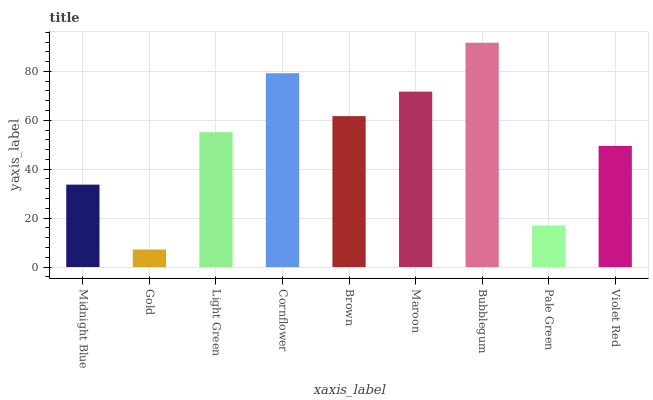Is Gold the minimum?
Answer yes or no. Yes. Is Bubblegum the maximum?
Answer yes or no. Yes. Is Light Green the minimum?
Answer yes or no. No. Is Light Green the maximum?
Answer yes or no. No. Is Light Green greater than Gold?
Answer yes or no. Yes. Is Gold less than Light Green?
Answer yes or no. Yes. Is Gold greater than Light Green?
Answer yes or no. No. Is Light Green less than Gold?
Answer yes or no. No. Is Light Green the high median?
Answer yes or no. Yes. Is Light Green the low median?
Answer yes or no. Yes. Is Brown the high median?
Answer yes or no. No. Is Gold the low median?
Answer yes or no. No. 